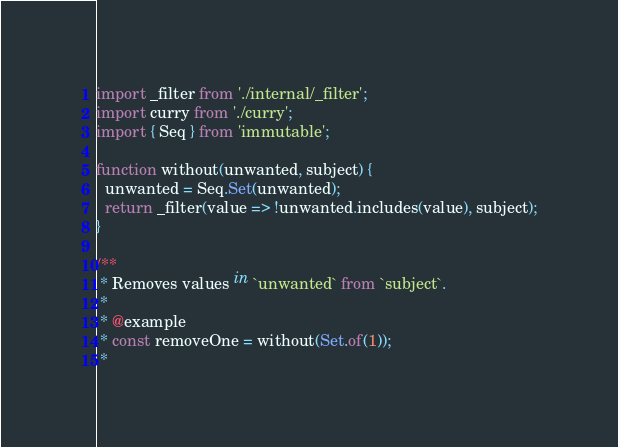<code> <loc_0><loc_0><loc_500><loc_500><_JavaScript_>import _filter from './internal/_filter';
import curry from './curry';
import { Seq } from 'immutable';

function without(unwanted, subject) {
  unwanted = Seq.Set(unwanted);
  return _filter(value => !unwanted.includes(value), subject);
}

/**
 * Removes values in `unwanted` from `subject`.
 *
 * @example
 * const removeOne = without(Set.of(1));
 *</code> 